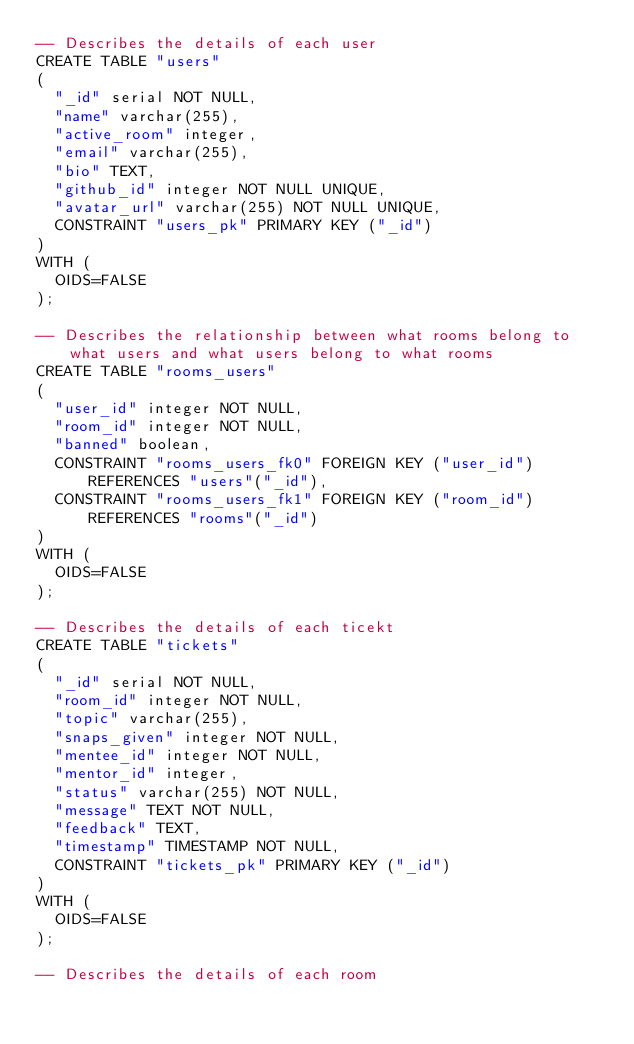Convert code to text. <code><loc_0><loc_0><loc_500><loc_500><_SQL_>-- Describes the details of each user
CREATE TABLE "users"
(
  "_id" serial NOT NULL,
  "name" varchar(255),
  "active_room" integer,
  "email" varchar(255),
  "bio" TEXT,
  "github_id" integer NOT NULL UNIQUE,
  "avatar_url" varchar(255) NOT NULL UNIQUE,
  CONSTRAINT "users_pk" PRIMARY KEY ("_id")
)
WITH (
  OIDS=FALSE
);

-- Describes the relationship between what rooms belong to what users and what users belong to what rooms
CREATE TABLE "rooms_users"
(
  "user_id" integer NOT NULL,
  "room_id" integer NOT NULL,
  "banned" boolean,
  CONSTRAINT "rooms_users_fk0" FOREIGN KEY ("user_id") REFERENCES "users"("_id"),
  CONSTRAINT "rooms_users_fk1" FOREIGN KEY ("room_id") REFERENCES "rooms"("_id")
)
WITH (
  OIDS=FALSE
);

-- Describes the details of each ticekt
CREATE TABLE "tickets"
(
  "_id" serial NOT NULL,
  "room_id" integer NOT NULL,
  "topic" varchar(255),
  "snaps_given" integer NOT NULL,
  "mentee_id" integer NOT NULL,
  "mentor_id" integer,
  "status" varchar(255) NOT NULL,
  "message" TEXT NOT NULL,
  "feedback" TEXT,
  "timestamp" TIMESTAMP NOT NULL,
  CONSTRAINT "tickets_pk" PRIMARY KEY ("_id")
)
WITH (
  OIDS=FALSE
);

-- Describes the details of each room</code> 